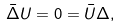Convert formula to latex. <formula><loc_0><loc_0><loc_500><loc_500>\bar { \Delta } U = 0 = \bar { U } \Delta ,</formula> 